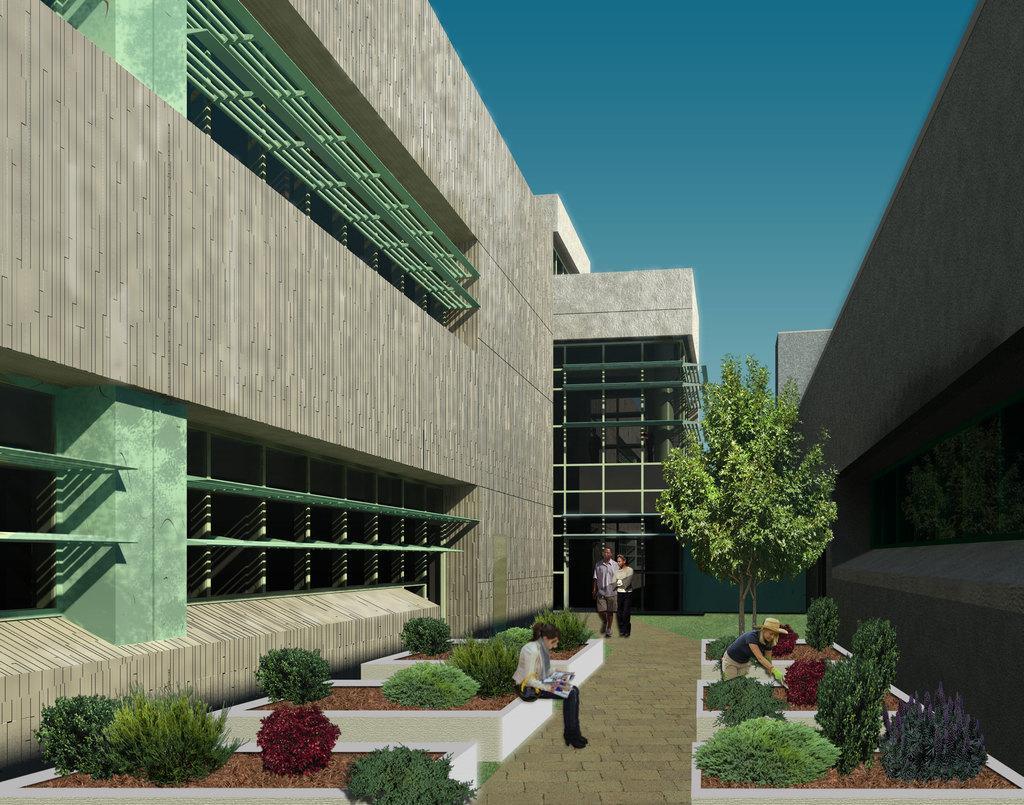Describe this image in one or two sentences. This image is an edited image in which there are plants, trees, buildings and persons. 